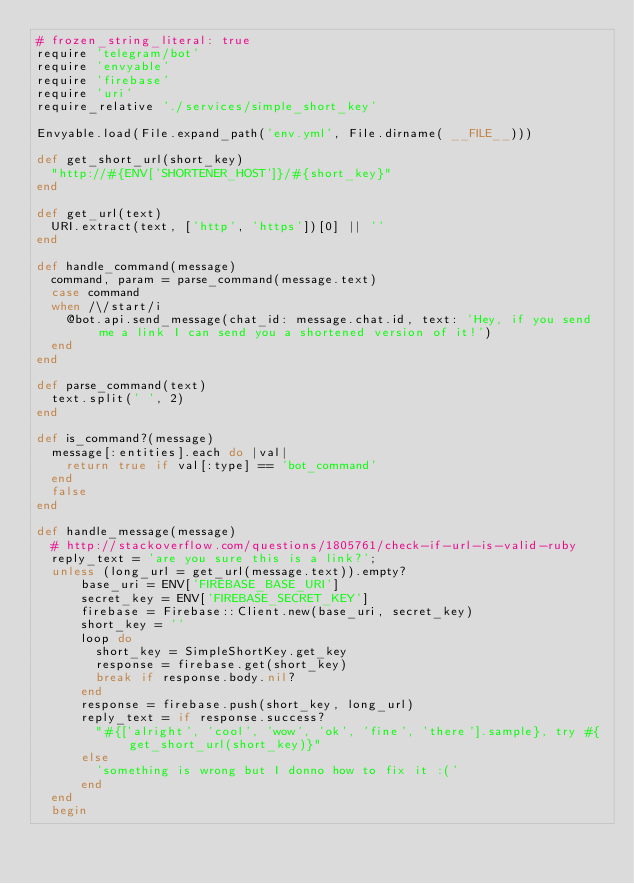<code> <loc_0><loc_0><loc_500><loc_500><_Ruby_># frozen_string_literal: true
require 'telegram/bot'
require 'envyable'
require 'firebase'
require 'uri'
require_relative './services/simple_short_key'

Envyable.load(File.expand_path('env.yml', File.dirname( __FILE__)))

def get_short_url(short_key)
  "http://#{ENV['SHORTENER_HOST']}/#{short_key}"
end

def get_url(text)
  URI.extract(text, ['http', 'https'])[0] || ''
end

def handle_command(message)
  command, param = parse_command(message.text)
  case command
  when /\/start/i
    @bot.api.send_message(chat_id: message.chat.id, text: 'Hey, if you send me a link I can send you a shortened version of it!')
  end
end

def parse_command(text)
  text.split(' ', 2)
end

def is_command?(message)
  message[:entities].each do |val|
    return true if val[:type] == 'bot_command'
  end
  false
end

def handle_message(message)
  # http://stackoverflow.com/questions/1805761/check-if-url-is-valid-ruby
  reply_text = 'are you sure this is a link?';
  unless (long_url = get_url(message.text)).empty?
      base_uri = ENV['FIREBASE_BASE_URI']
      secret_key = ENV['FIREBASE_SECRET_KEY']
      firebase = Firebase::Client.new(base_uri, secret_key)
      short_key = ''
      loop do
        short_key = SimpleShortKey.get_key
        response = firebase.get(short_key)
        break if response.body.nil?
      end
      response = firebase.push(short_key, long_url)
      reply_text = if response.success?
        "#{['alright', 'cool', 'wow', 'ok', 'fine', 'there'].sample}, try #{get_short_url(short_key)}"
      else
        'something is wrong but I donno how to fix it :('
      end
  end
  begin</code> 